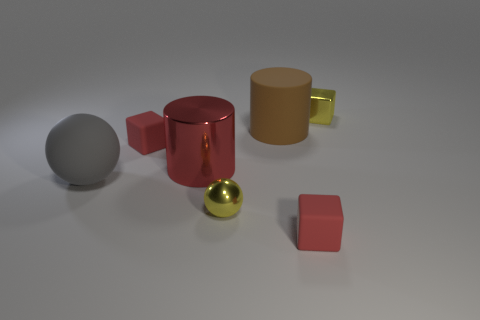The yellow metallic sphere is what size?
Provide a short and direct response. Small. The big object that is behind the big gray matte ball and on the left side of the small yellow ball has what shape?
Offer a very short reply. Cylinder. How many gray things are shiny blocks or big objects?
Give a very brief answer. 1. Do the red thing that is in front of the big red cylinder and the yellow object behind the large rubber ball have the same size?
Provide a succinct answer. Yes. What number of objects are big gray rubber things or big cyan objects?
Keep it short and to the point. 1. Is there another big thing that has the same shape as the brown thing?
Keep it short and to the point. Yes. Is the number of red blocks less than the number of tiny brown cylinders?
Offer a terse response. No. Does the brown thing have the same shape as the gray rubber thing?
Provide a short and direct response. No. How many things are yellow metallic spheres or small yellow objects that are behind the big brown object?
Your answer should be very brief. 2. What number of cyan metallic spheres are there?
Provide a short and direct response. 0. 